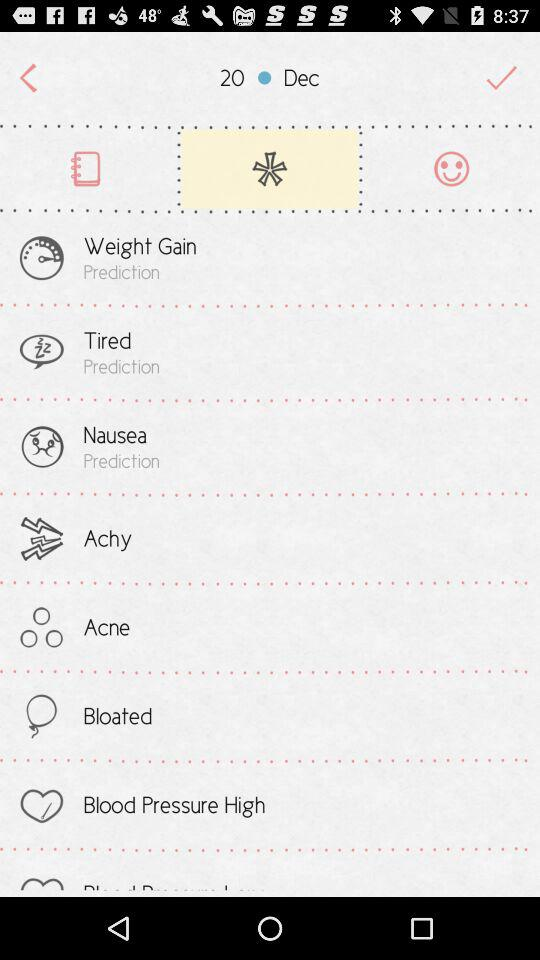What is the date? The date is December 20. 